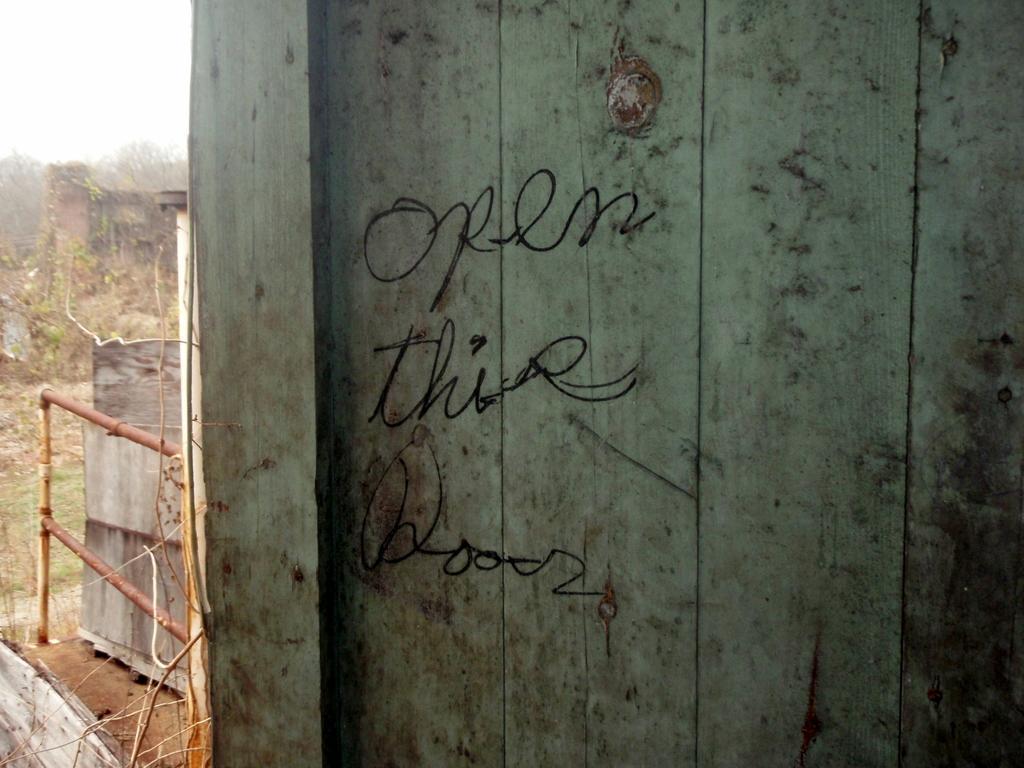Can you describe this image briefly? This looks like a wooden door. These are the letters written on the door. In the background, I can see the plants. This looks like a wooden object. 